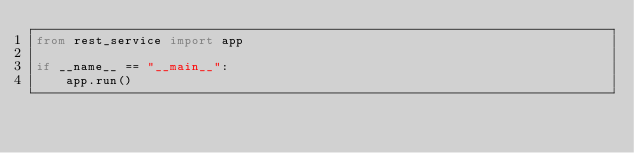Convert code to text. <code><loc_0><loc_0><loc_500><loc_500><_Python_>from rest_service import app

if __name__ == "__main__":
    app.run()

</code> 